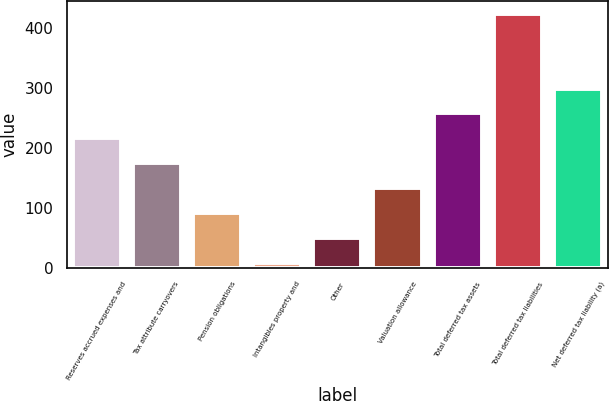<chart> <loc_0><loc_0><loc_500><loc_500><bar_chart><fcel>Reserves accrued expenses and<fcel>Tax attribute carryovers<fcel>Pension obligations<fcel>Intangibles property and<fcel>Other<fcel>Valuation allowance<fcel>Total deferred tax assets<fcel>Total deferred tax liabilities<fcel>Net deferred tax liability (a)<nl><fcel>215.65<fcel>174.1<fcel>91<fcel>7.9<fcel>49.45<fcel>132.55<fcel>257.2<fcel>423.4<fcel>298.75<nl></chart> 